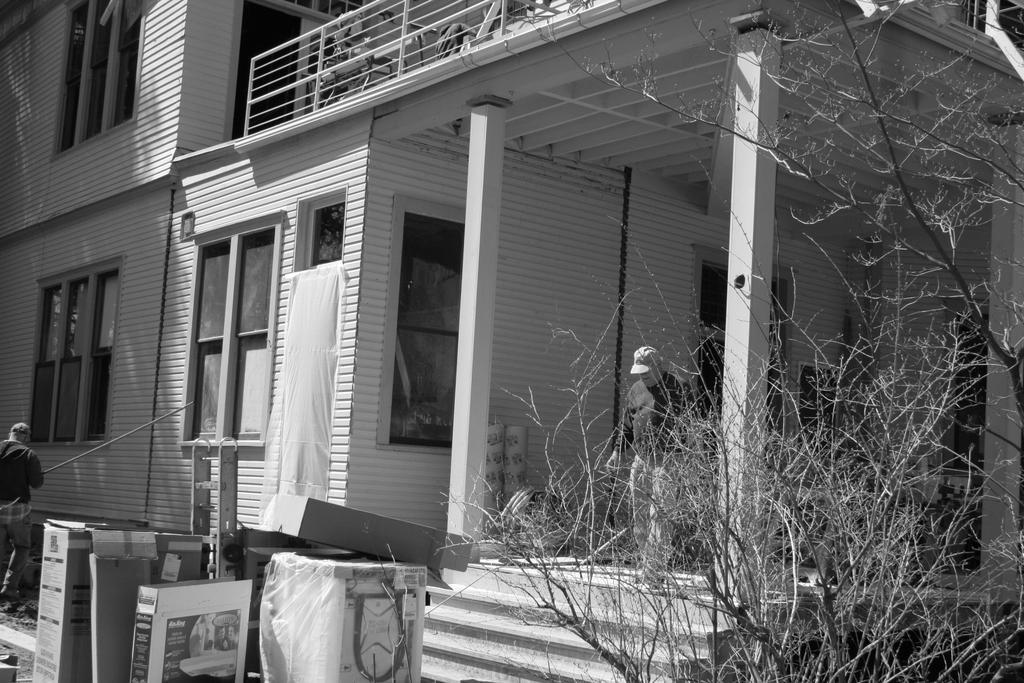Please provide a concise description of this image. In this picture there is a woman who is wearing cap, t-shirt and shoe. He is standing near to the stairs, beside him we can see the building. At the top there is a fencing. On the left we can see the windows. At the bottom we can see the dustbins, plastic covers and plants. 